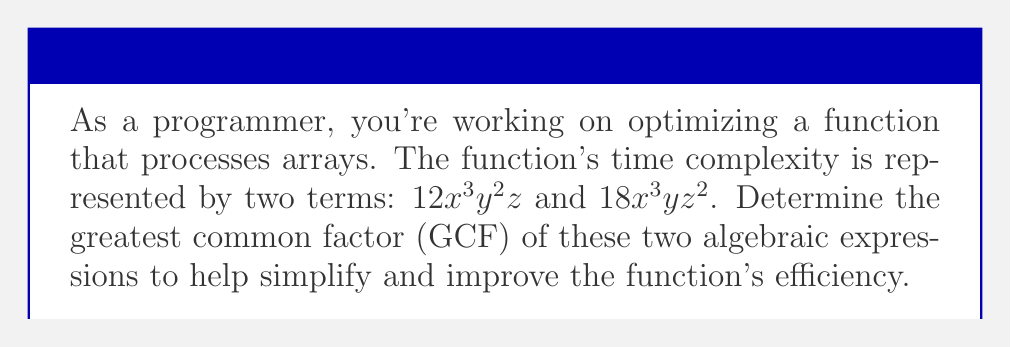Teach me how to tackle this problem. To find the GCF of $12x^3y^2z$ and $18x^3yz^2$, we'll follow these steps:

1. Factor out the numerical coefficients:
   $12x^3y^2z = 2^2 \cdot 3 \cdot x^3y^2z$
   $18x^3yz^2 = 2 \cdot 3^2 \cdot x^3yz^2$

2. Identify the common factors:
   - Numerical: $GCF(12, 18) = 6 = 2 \cdot 3$
   - $x$: $x^3$ (common in both terms)
   - $y$: $y^1$ (lowest power of $y$)
   - $z$: $z^1$ (lowest power of $z$)

3. Combine the common factors:
   $GCF = 6 \cdot x^3 \cdot y \cdot z = 6x^3yz$

This GCF represents the common factor that can be extracted from both terms, potentially simplifying the time complexity expression and improving the function's readability and efficiency.
Answer: $6x^3yz$ 